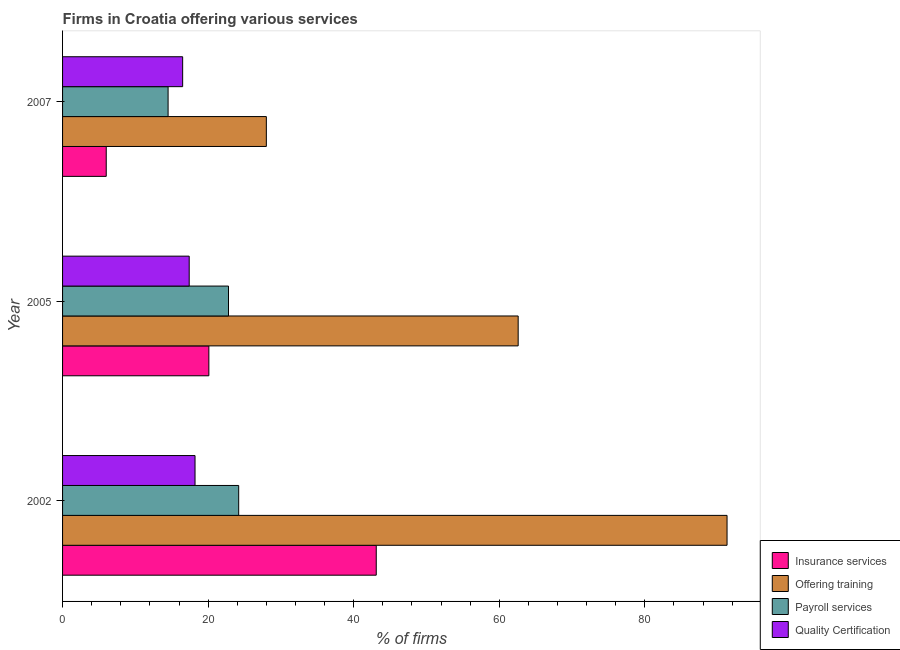How many different coloured bars are there?
Your response must be concise. 4. Are the number of bars per tick equal to the number of legend labels?
Offer a very short reply. Yes. How many bars are there on the 2nd tick from the bottom?
Ensure brevity in your answer.  4. What is the label of the 2nd group of bars from the top?
Provide a short and direct response. 2005. In how many cases, is the number of bars for a given year not equal to the number of legend labels?
Your answer should be very brief. 0. What is the percentage of firms offering insurance services in 2005?
Provide a short and direct response. 20.1. Across all years, what is the maximum percentage of firms offering training?
Offer a terse response. 91.3. Across all years, what is the minimum percentage of firms offering training?
Your answer should be very brief. 28. In which year was the percentage of firms offering payroll services maximum?
Your answer should be compact. 2002. What is the total percentage of firms offering payroll services in the graph?
Provide a succinct answer. 61.5. What is the difference between the percentage of firms offering insurance services in 2002 and the percentage of firms offering training in 2007?
Make the answer very short. 15.1. What is the average percentage of firms offering payroll services per year?
Your response must be concise. 20.5. In the year 2002, what is the difference between the percentage of firms offering quality certification and percentage of firms offering training?
Provide a short and direct response. -73.1. What is the ratio of the percentage of firms offering insurance services in 2002 to that in 2005?
Your answer should be compact. 2.14. What is the difference between the highest and the lowest percentage of firms offering training?
Give a very brief answer. 63.3. In how many years, is the percentage of firms offering insurance services greater than the average percentage of firms offering insurance services taken over all years?
Offer a terse response. 1. Is the sum of the percentage of firms offering payroll services in 2002 and 2007 greater than the maximum percentage of firms offering training across all years?
Ensure brevity in your answer.  No. What does the 4th bar from the top in 2007 represents?
Offer a terse response. Insurance services. What does the 3rd bar from the bottom in 2002 represents?
Give a very brief answer. Payroll services. Is it the case that in every year, the sum of the percentage of firms offering insurance services and percentage of firms offering training is greater than the percentage of firms offering payroll services?
Ensure brevity in your answer.  Yes. Are all the bars in the graph horizontal?
Keep it short and to the point. Yes. Are the values on the major ticks of X-axis written in scientific E-notation?
Provide a short and direct response. No. Does the graph contain any zero values?
Offer a terse response. No. Where does the legend appear in the graph?
Offer a terse response. Bottom right. How many legend labels are there?
Offer a terse response. 4. What is the title of the graph?
Offer a terse response. Firms in Croatia offering various services . Does "Natural Gas" appear as one of the legend labels in the graph?
Your answer should be very brief. No. What is the label or title of the X-axis?
Ensure brevity in your answer.  % of firms. What is the % of firms in Insurance services in 2002?
Your response must be concise. 43.1. What is the % of firms of Offering training in 2002?
Offer a terse response. 91.3. What is the % of firms in Payroll services in 2002?
Offer a very short reply. 24.2. What is the % of firms of Insurance services in 2005?
Provide a short and direct response. 20.1. What is the % of firms of Offering training in 2005?
Make the answer very short. 62.6. What is the % of firms in Payroll services in 2005?
Your response must be concise. 22.8. What is the % of firms of Offering training in 2007?
Keep it short and to the point. 28. What is the % of firms in Payroll services in 2007?
Offer a very short reply. 14.5. Across all years, what is the maximum % of firms of Insurance services?
Make the answer very short. 43.1. Across all years, what is the maximum % of firms of Offering training?
Ensure brevity in your answer.  91.3. Across all years, what is the maximum % of firms of Payroll services?
Your response must be concise. 24.2. Across all years, what is the minimum % of firms of Insurance services?
Provide a succinct answer. 6. Across all years, what is the minimum % of firms in Quality Certification?
Offer a terse response. 16.5. What is the total % of firms in Insurance services in the graph?
Ensure brevity in your answer.  69.2. What is the total % of firms in Offering training in the graph?
Your answer should be very brief. 181.9. What is the total % of firms of Payroll services in the graph?
Provide a succinct answer. 61.5. What is the total % of firms in Quality Certification in the graph?
Provide a succinct answer. 52.1. What is the difference between the % of firms in Offering training in 2002 and that in 2005?
Ensure brevity in your answer.  28.7. What is the difference between the % of firms of Insurance services in 2002 and that in 2007?
Provide a succinct answer. 37.1. What is the difference between the % of firms of Offering training in 2002 and that in 2007?
Give a very brief answer. 63.3. What is the difference between the % of firms in Payroll services in 2002 and that in 2007?
Make the answer very short. 9.7. What is the difference between the % of firms in Quality Certification in 2002 and that in 2007?
Keep it short and to the point. 1.7. What is the difference between the % of firms of Offering training in 2005 and that in 2007?
Your response must be concise. 34.6. What is the difference between the % of firms of Payroll services in 2005 and that in 2007?
Offer a terse response. 8.3. What is the difference between the % of firms of Insurance services in 2002 and the % of firms of Offering training in 2005?
Your answer should be compact. -19.5. What is the difference between the % of firms of Insurance services in 2002 and the % of firms of Payroll services in 2005?
Your answer should be very brief. 20.3. What is the difference between the % of firms in Insurance services in 2002 and the % of firms in Quality Certification in 2005?
Provide a short and direct response. 25.7. What is the difference between the % of firms of Offering training in 2002 and the % of firms of Payroll services in 2005?
Make the answer very short. 68.5. What is the difference between the % of firms of Offering training in 2002 and the % of firms of Quality Certification in 2005?
Ensure brevity in your answer.  73.9. What is the difference between the % of firms in Payroll services in 2002 and the % of firms in Quality Certification in 2005?
Provide a short and direct response. 6.8. What is the difference between the % of firms in Insurance services in 2002 and the % of firms in Payroll services in 2007?
Offer a very short reply. 28.6. What is the difference between the % of firms in Insurance services in 2002 and the % of firms in Quality Certification in 2007?
Ensure brevity in your answer.  26.6. What is the difference between the % of firms in Offering training in 2002 and the % of firms in Payroll services in 2007?
Provide a short and direct response. 76.8. What is the difference between the % of firms in Offering training in 2002 and the % of firms in Quality Certification in 2007?
Ensure brevity in your answer.  74.8. What is the difference between the % of firms of Insurance services in 2005 and the % of firms of Payroll services in 2007?
Offer a very short reply. 5.6. What is the difference between the % of firms of Insurance services in 2005 and the % of firms of Quality Certification in 2007?
Your response must be concise. 3.6. What is the difference between the % of firms of Offering training in 2005 and the % of firms of Payroll services in 2007?
Provide a succinct answer. 48.1. What is the difference between the % of firms of Offering training in 2005 and the % of firms of Quality Certification in 2007?
Provide a succinct answer. 46.1. What is the average % of firms of Insurance services per year?
Ensure brevity in your answer.  23.07. What is the average % of firms in Offering training per year?
Make the answer very short. 60.63. What is the average % of firms in Payroll services per year?
Provide a succinct answer. 20.5. What is the average % of firms in Quality Certification per year?
Give a very brief answer. 17.37. In the year 2002, what is the difference between the % of firms in Insurance services and % of firms in Offering training?
Provide a short and direct response. -48.2. In the year 2002, what is the difference between the % of firms of Insurance services and % of firms of Payroll services?
Make the answer very short. 18.9. In the year 2002, what is the difference between the % of firms of Insurance services and % of firms of Quality Certification?
Offer a terse response. 24.9. In the year 2002, what is the difference between the % of firms in Offering training and % of firms in Payroll services?
Your response must be concise. 67.1. In the year 2002, what is the difference between the % of firms in Offering training and % of firms in Quality Certification?
Your answer should be very brief. 73.1. In the year 2002, what is the difference between the % of firms of Payroll services and % of firms of Quality Certification?
Make the answer very short. 6. In the year 2005, what is the difference between the % of firms in Insurance services and % of firms in Offering training?
Keep it short and to the point. -42.5. In the year 2005, what is the difference between the % of firms in Insurance services and % of firms in Payroll services?
Your answer should be very brief. -2.7. In the year 2005, what is the difference between the % of firms in Insurance services and % of firms in Quality Certification?
Offer a terse response. 2.7. In the year 2005, what is the difference between the % of firms of Offering training and % of firms of Payroll services?
Offer a very short reply. 39.8. In the year 2005, what is the difference between the % of firms of Offering training and % of firms of Quality Certification?
Ensure brevity in your answer.  45.2. In the year 2005, what is the difference between the % of firms of Payroll services and % of firms of Quality Certification?
Your answer should be very brief. 5.4. In the year 2007, what is the difference between the % of firms of Insurance services and % of firms of Quality Certification?
Offer a terse response. -10.5. In the year 2007, what is the difference between the % of firms in Offering training and % of firms in Payroll services?
Your answer should be very brief. 13.5. What is the ratio of the % of firms in Insurance services in 2002 to that in 2005?
Make the answer very short. 2.14. What is the ratio of the % of firms in Offering training in 2002 to that in 2005?
Your answer should be very brief. 1.46. What is the ratio of the % of firms of Payroll services in 2002 to that in 2005?
Ensure brevity in your answer.  1.06. What is the ratio of the % of firms of Quality Certification in 2002 to that in 2005?
Offer a very short reply. 1.05. What is the ratio of the % of firms of Insurance services in 2002 to that in 2007?
Provide a succinct answer. 7.18. What is the ratio of the % of firms in Offering training in 2002 to that in 2007?
Give a very brief answer. 3.26. What is the ratio of the % of firms in Payroll services in 2002 to that in 2007?
Make the answer very short. 1.67. What is the ratio of the % of firms of Quality Certification in 2002 to that in 2007?
Ensure brevity in your answer.  1.1. What is the ratio of the % of firms of Insurance services in 2005 to that in 2007?
Your answer should be very brief. 3.35. What is the ratio of the % of firms of Offering training in 2005 to that in 2007?
Make the answer very short. 2.24. What is the ratio of the % of firms of Payroll services in 2005 to that in 2007?
Offer a very short reply. 1.57. What is the ratio of the % of firms in Quality Certification in 2005 to that in 2007?
Provide a succinct answer. 1.05. What is the difference between the highest and the second highest % of firms in Offering training?
Your answer should be compact. 28.7. What is the difference between the highest and the second highest % of firms in Payroll services?
Your answer should be compact. 1.4. What is the difference between the highest and the lowest % of firms of Insurance services?
Provide a succinct answer. 37.1. What is the difference between the highest and the lowest % of firms in Offering training?
Provide a short and direct response. 63.3. 